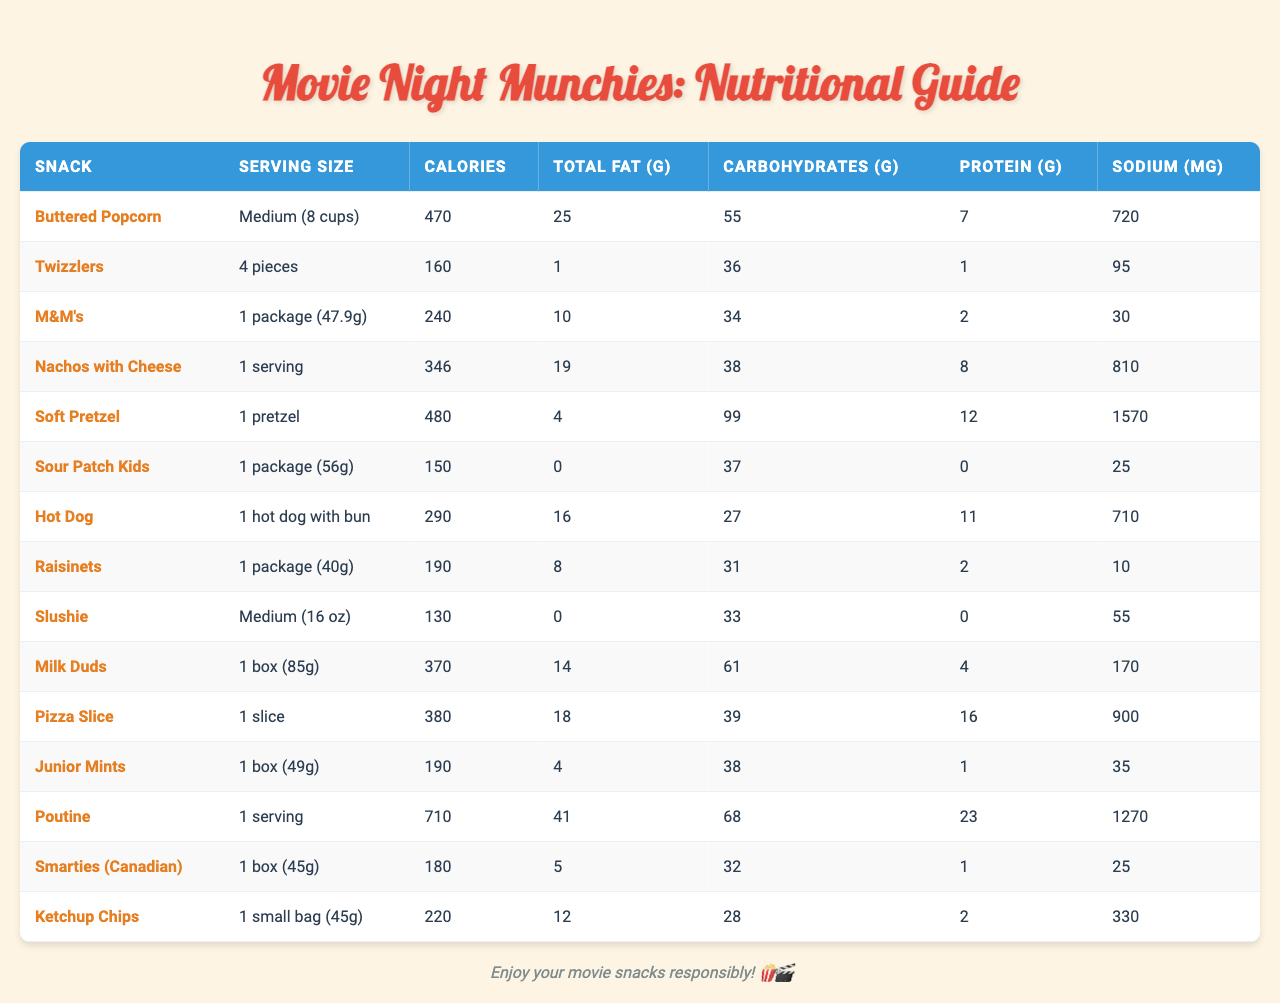What is the calorie count for a medium serving of buttered popcorn? The table states that medium buttered popcorn contains 470 calories.
Answer: 470 calories How much total fat is in a serving of nachos with cheese? The table shows that nachos with cheese contain 19 grams of total fat.
Answer: 19 grams Which snack has the highest sodium content? By checking the sodium values, the soft pretzel has the highest sodium content at 1570 mg.
Answer: Soft Pretzel What is the total carbohydrate content for M&M's and Raisinets combined? M&M's have 34 grams and Raisinets have 31 grams. Adding them together: 34 + 31 = 65 grams.
Answer: 65 grams Is there any snack in the table that contains zero grams of protein? Sour Patch Kids have 0 grams of protein, as listed in the table. The answer is yes.
Answer: Yes What is the average calorie count of the snacks listed in the table? There are 14 snacks listed, and the total calorie count is 470 + 160 + 240 + 346 + 480 + 150 + 290 + 190 + 130 + 370 + 380 + 190 + 710 + 180 + 220 = 3546 calories. Dividing by 14 gives an average of 3546 / 14 = 253.29.
Answer: Approximately 253 calories How much more sodium does poutine have compared to a hot dog? Poutine has 1270 mg of sodium and hot dogs have 710 mg. The difference is calculated as 1270 - 710 = 560 mg.
Answer: 560 mg Which snack has the least calories, and what is that value? Sour Patch Kids have the least calories at 150.
Answer: 150 calories What is the total protein content if you have one serving each of buttered popcorn, hot dog, and milk duds? Buttered popcorn has 7g, hot dog has 11g, and milk duds have 4g. Adding: 7 + 11 + 4 = 22 grams of protein.
Answer: 22 grams Which snack has a higher calorie count, pizza slice or poutine? Pizza slice has 380 calories, while poutine has 710 calories. Poutine has a higher calorie count.
Answer: Poutine 